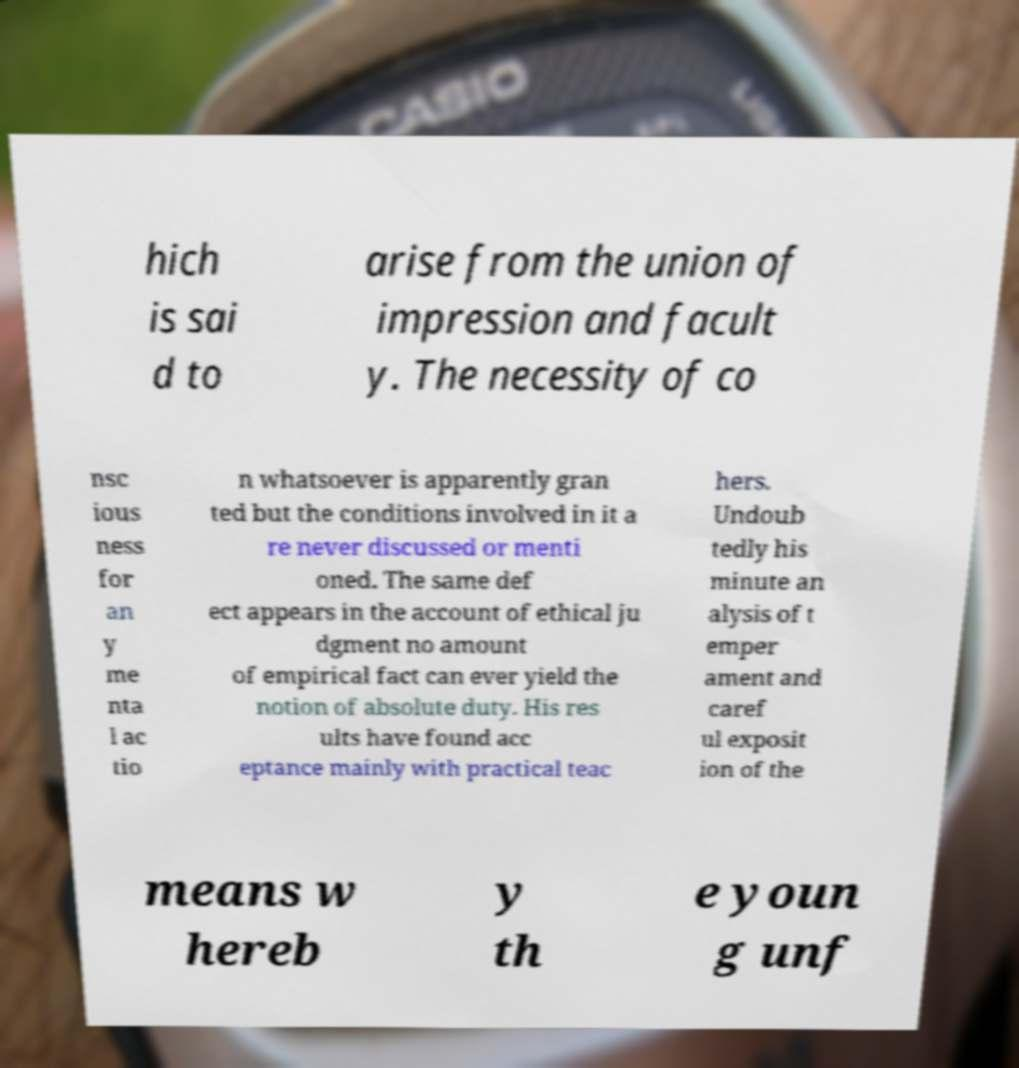Can you read and provide the text displayed in the image?This photo seems to have some interesting text. Can you extract and type it out for me? hich is sai d to arise from the union of impression and facult y. The necessity of co nsc ious ness for an y me nta l ac tio n whatsoever is apparently gran ted but the conditions involved in it a re never discussed or menti oned. The same def ect appears in the account of ethical ju dgment no amount of empirical fact can ever yield the notion of absolute duty. His res ults have found acc eptance mainly with practical teac hers. Undoub tedly his minute an alysis of t emper ament and caref ul exposit ion of the means w hereb y th e youn g unf 